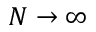<formula> <loc_0><loc_0><loc_500><loc_500>N \to \infty</formula> 